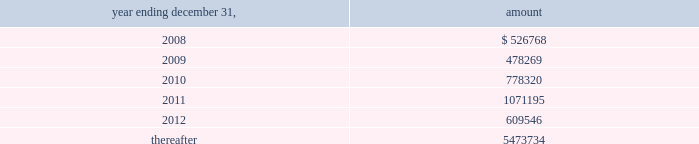Vornado realty trust notes to consolidated financial statements ( continued ) 9 .
Debt - continued our revolving credit facility and senior unsecured notes contain financial covenants which require us to maintain minimum interest coverage ratios and limit our debt to market capitalization ratios .
We believe that we have complied with all of our financial covenants as of december 31 , 2007 .
On may 9 , 2006 , we executed supplemental indentures with respect to our senior unsecured notes due 2007 , 2009 and 2010 ( collectively , the 201cnotes 201d ) , pursuant to our consent solicitation statement dated april 18 , 2006 , as amended .
Holders of approximately 96.7% ( 96.7 % ) of the aggregate principal amount of the notes consented to the solicitation .
The supplemental indentures contain modifications of certain covenants and related defined terms governing the terms of the notes to make them consistent with corresponding provisions of the covenants and defined terms included in the senior unsecured notes due 2011 issued on february 16 , 2006 .
The supplemental indentures also include a new covenant that provides for an increase in the interest rate of the notes upon certain decreases in the ratings assigned by rating agencies to the notes .
In connection with the consent solicitation we paid an aggregate fee of $ 2241000 to the consenting note holders , which will be amortized into expense over the remaining term of the notes .
In addition , we incurred advisory and professional fees aggregating $ 1415000 , which were expensed in 2006 .
The net carrying amount of properties collateralizing the notes and mortgages payable amounted to $ 10.920 billion at december 31 , 2007 .
As at december 31 , 2007 , the principal repayments required for the next five years and thereafter are as follows : ( amounts in thousands ) .

Principal payments required for 2009 were what percent of those for 2010? 
Computations: (478269 / 778320)
Answer: 0.61449. 